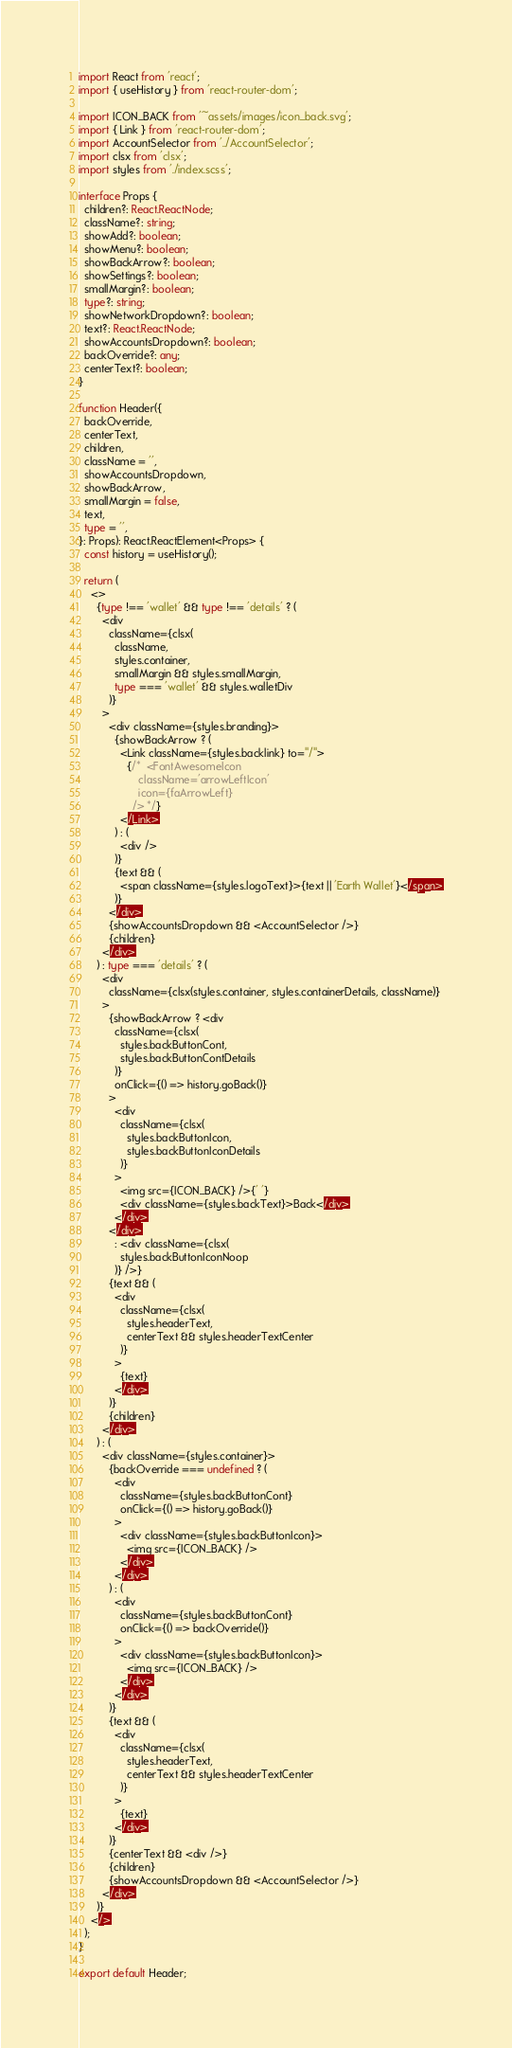Convert code to text. <code><loc_0><loc_0><loc_500><loc_500><_TypeScript_>import React from 'react';
import { useHistory } from 'react-router-dom';

import ICON_BACK from '~assets/images/icon_back.svg';
import { Link } from 'react-router-dom';
import AccountSelector from '../AccountSelector';
import clsx from 'clsx';
import styles from './index.scss';

interface Props {
  children?: React.ReactNode;
  className?: string;
  showAdd?: boolean;
  showMenu?: boolean;
  showBackArrow?: boolean;
  showSettings?: boolean;
  smallMargin?: boolean;
  type?: string;
  showNetworkDropdown?: boolean;
  text?: React.ReactNode;
  showAccountsDropdown?: boolean;
  backOverride?: any;
  centerText?: boolean;
}

function Header({
  backOverride,
  centerText,
  children,
  className = '',
  showAccountsDropdown,
  showBackArrow,
  smallMargin = false,
  text,
  type = '',
}: Props): React.ReactElement<Props> {
  const history = useHistory();

  return (
    <>
      {type !== 'wallet' && type !== 'details' ? (
        <div
          className={clsx(
            className,
            styles.container,
            smallMargin && styles.smallMargin,
            type === 'wallet' && styles.walletDiv
          )}
        >
          <div className={styles.branding}>
            {showBackArrow ? (
              <Link className={styles.backlink} to="/">
                {/*  <FontAwesomeIcon
                    className='arrowLeftIcon'
                    icon={faArrowLeft}
                  /> */}
              </Link>
            ) : (
              <div />
            )}
            {text && (
              <span className={styles.logoText}>{text || 'Earth Wallet'}</span>
            )}
          </div>
          {showAccountsDropdown && <AccountSelector />}
          {children}
        </div>
      ) : type === 'details' ? (
        <div
          className={clsx(styles.container, styles.containerDetails, className)}
        >
          {showBackArrow ? <div
            className={clsx(
              styles.backButtonCont,
              styles.backButtonContDetails
            )}
            onClick={() => history.goBack()}
          >
            <div
              className={clsx(
                styles.backButtonIcon,
                styles.backButtonIconDetails
              )}
            >
              <img src={ICON_BACK} />{' '}
              <div className={styles.backText}>Back</div>
            </div>
          </div>
            : <div className={clsx(
              styles.backButtonIconNoop
            )} />}
          {text && (
            <div
              className={clsx(
                styles.headerText,
                centerText && styles.headerTextCenter
              )}
            >
              {text}
            </div>
          )}
          {children}
        </div>
      ) : (
        <div className={styles.container}>
          {backOverride === undefined ? (
            <div
              className={styles.backButtonCont}
              onClick={() => history.goBack()}
            >
              <div className={styles.backButtonIcon}>
                <img src={ICON_BACK} />
              </div>
            </div>
          ) : (
            <div
              className={styles.backButtonCont}
              onClick={() => backOverride()}
            >
              <div className={styles.backButtonIcon}>
                <img src={ICON_BACK} />
              </div>
            </div>
          )}
          {text && (
            <div
              className={clsx(
                styles.headerText,
                centerText && styles.headerTextCenter
              )}
            >
              {text}
            </div>
          )}
          {centerText && <div />}
          {children}
          {showAccountsDropdown && <AccountSelector />}
        </div>
      )}
    </>
  );
}

export default Header;
</code> 